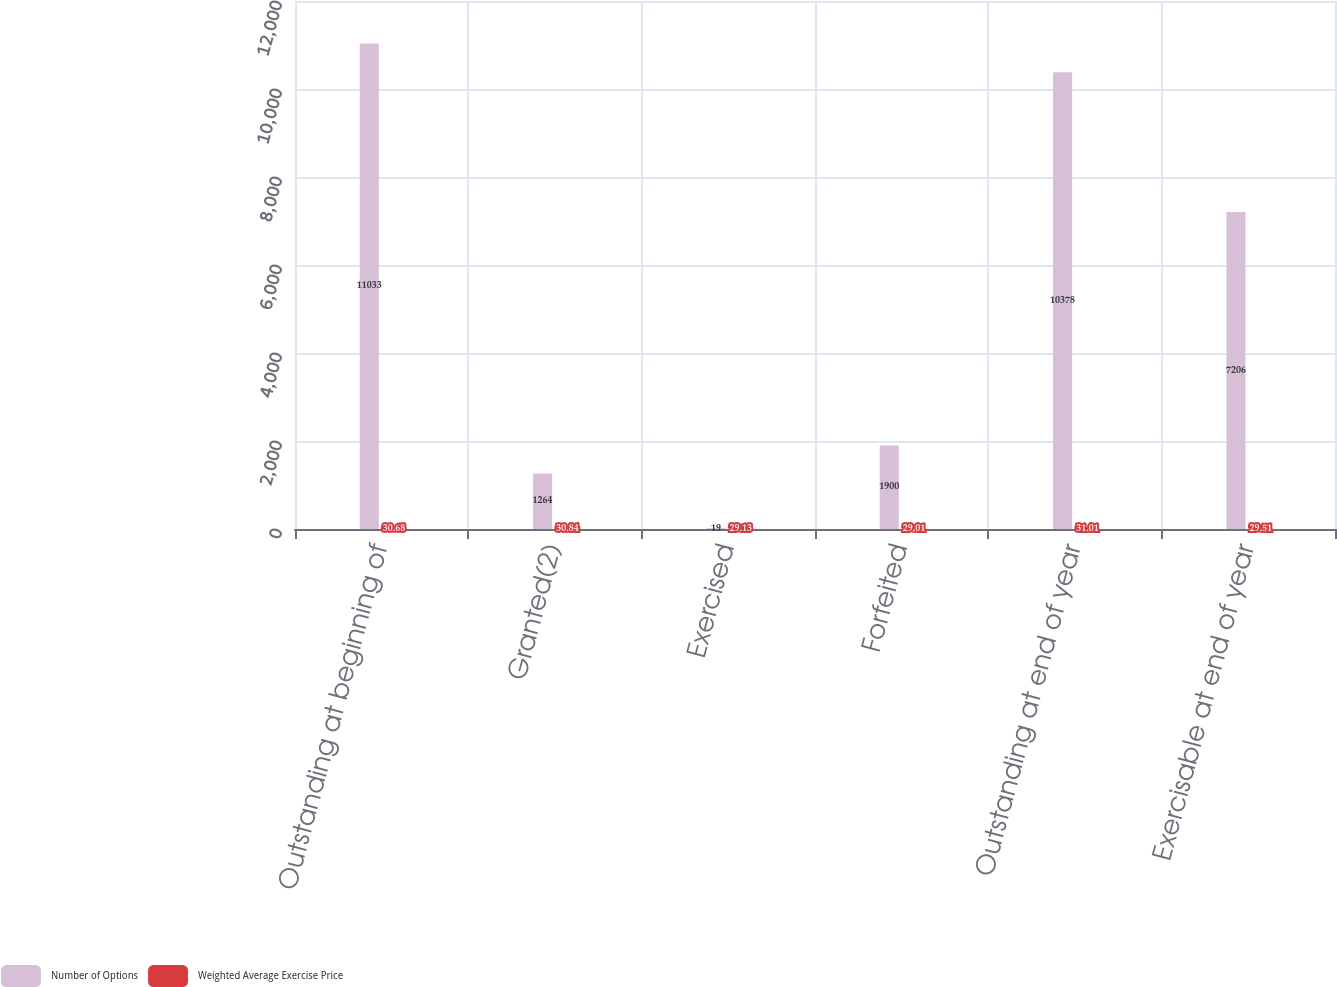<chart> <loc_0><loc_0><loc_500><loc_500><stacked_bar_chart><ecel><fcel>Outstanding at beginning of<fcel>Granted(2)<fcel>Exercised<fcel>Forfeited<fcel>Outstanding at end of year<fcel>Exercisable at end of year<nl><fcel>Number of Options<fcel>11033<fcel>1264<fcel>19<fcel>1900<fcel>10378<fcel>7206<nl><fcel>Weighted Average Exercise Price<fcel>30.68<fcel>30.84<fcel>29.13<fcel>29.01<fcel>31.01<fcel>29.51<nl></chart> 